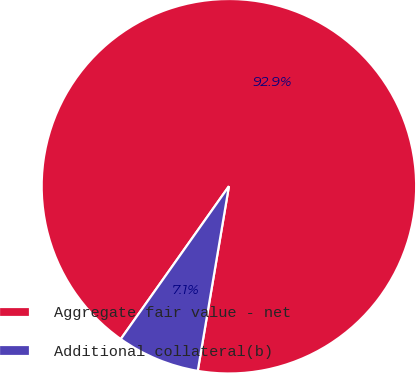Convert chart to OTSL. <chart><loc_0><loc_0><loc_500><loc_500><pie_chart><fcel>Aggregate fair value - net<fcel>Additional collateral(b)<nl><fcel>92.86%<fcel>7.14%<nl></chart> 